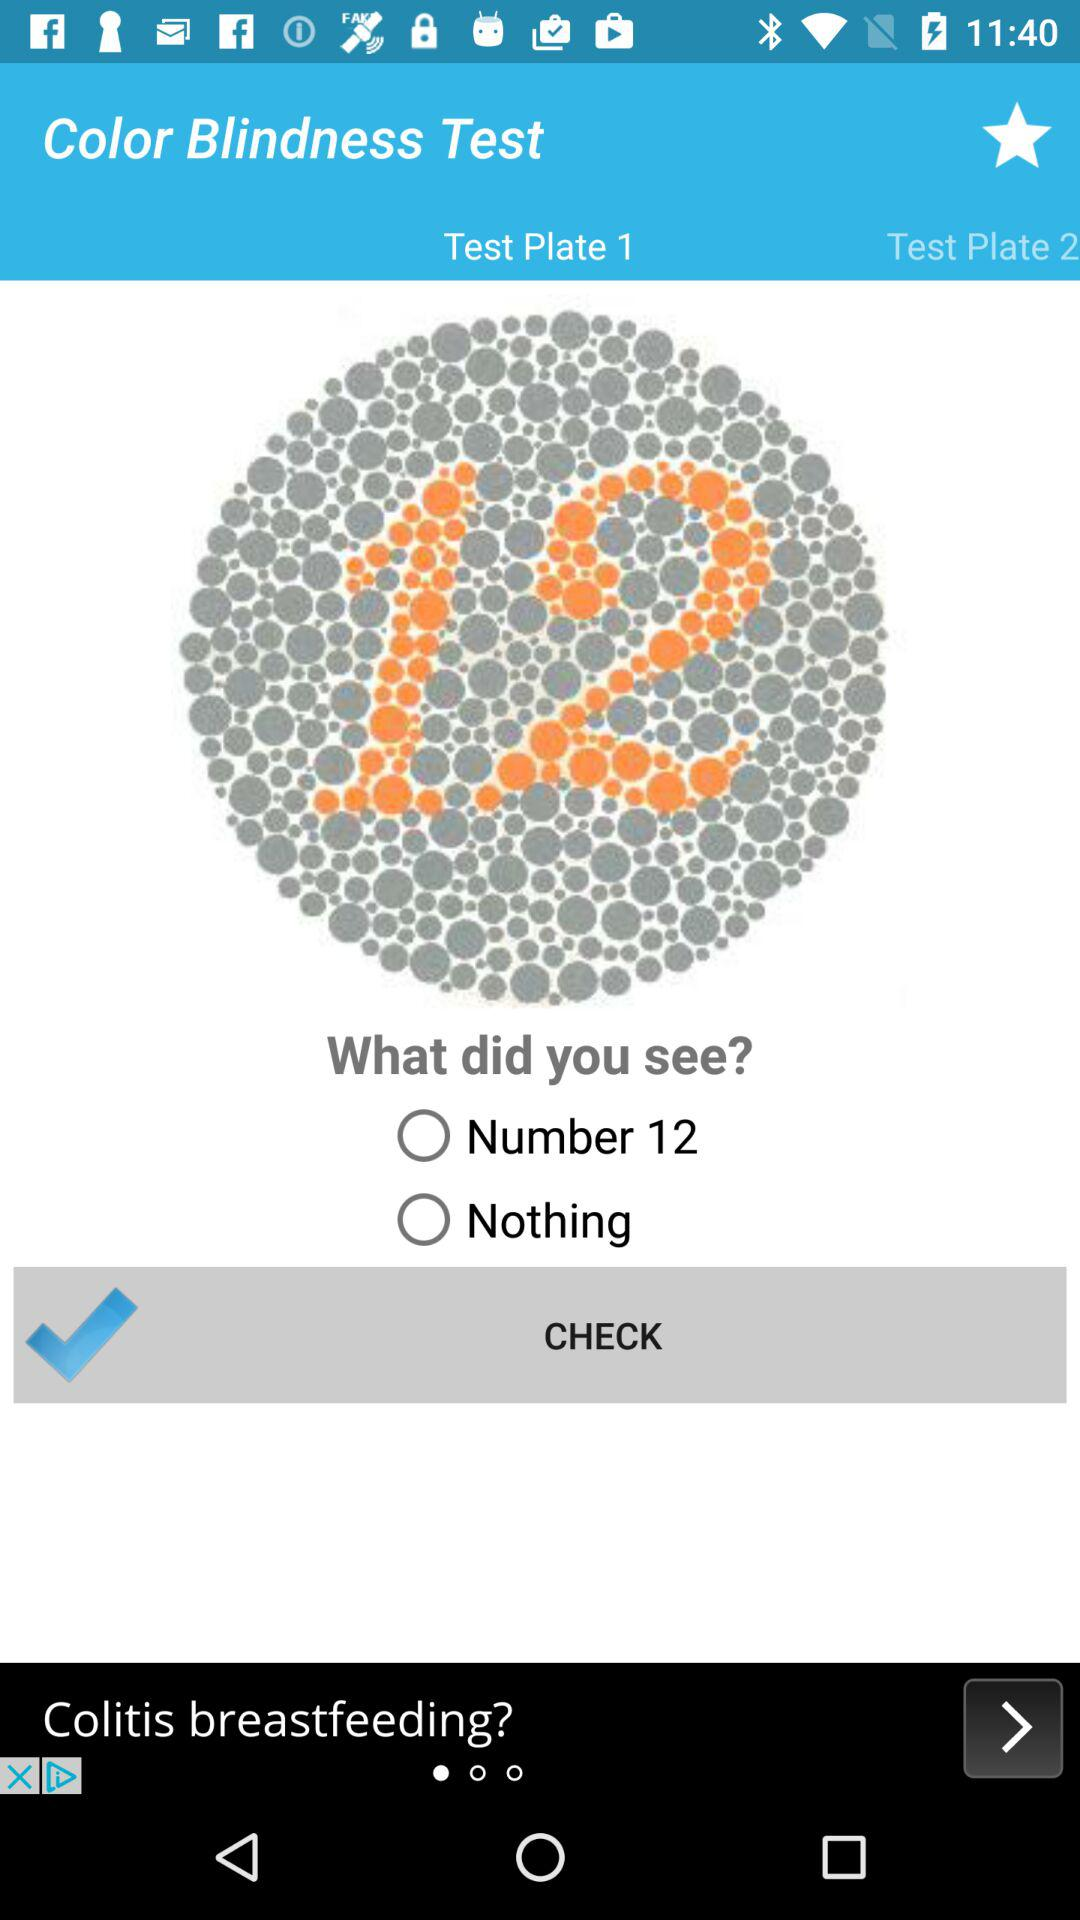Which tab is selected? The selected tab is "Test Plate 1". 